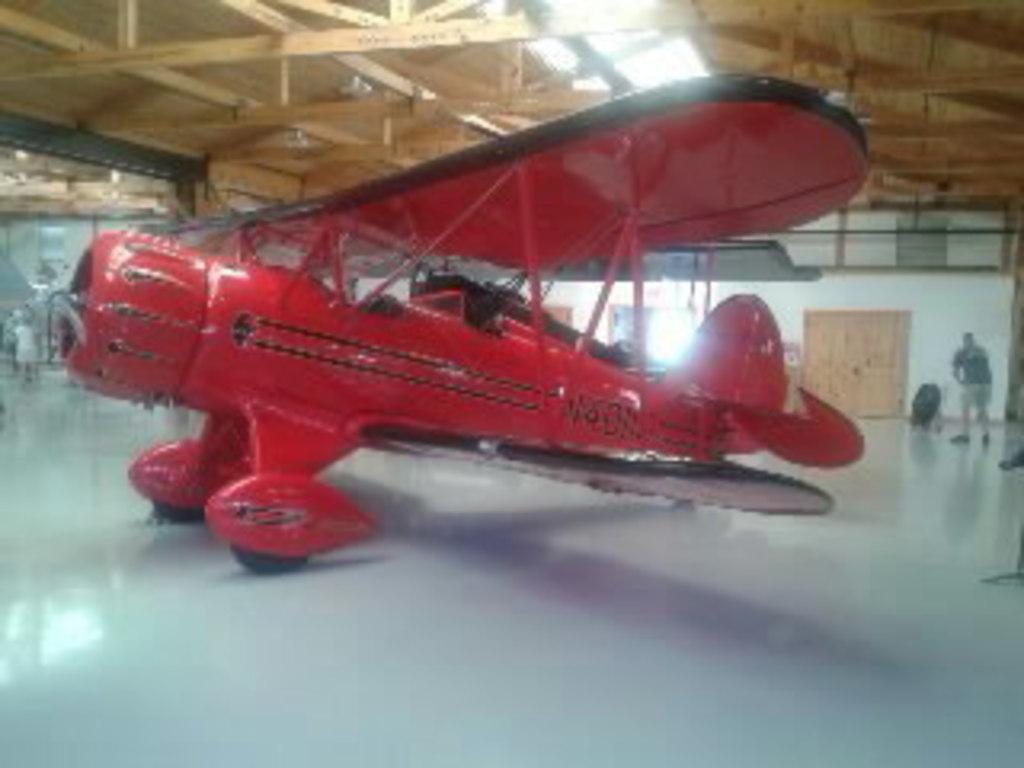How would you summarize this image in a sentence or two? In this image there are a few people and a depiction of an airplane, behind that there are wooden doors on the walls, at the top of the image there is a wooden roof top with wooden sticks. 